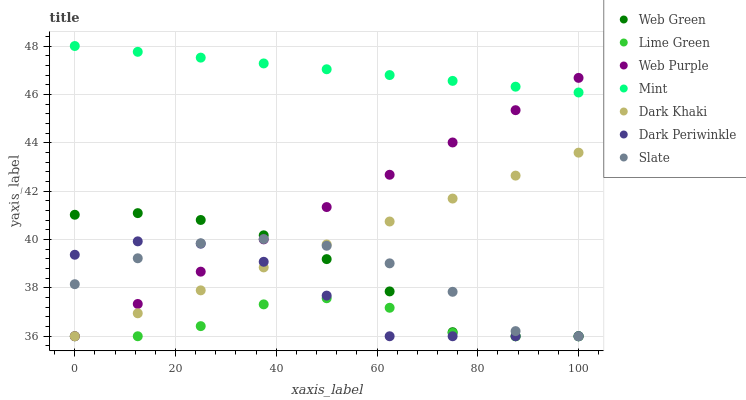Does Lime Green have the minimum area under the curve?
Answer yes or no. Yes. Does Mint have the maximum area under the curve?
Answer yes or no. Yes. Does Slate have the minimum area under the curve?
Answer yes or no. No. Does Slate have the maximum area under the curve?
Answer yes or no. No. Is Dark Khaki the smoothest?
Answer yes or no. Yes. Is Slate the roughest?
Answer yes or no. Yes. Is Web Green the smoothest?
Answer yes or no. No. Is Web Green the roughest?
Answer yes or no. No. Does Lime Green have the lowest value?
Answer yes or no. Yes. Does Mint have the lowest value?
Answer yes or no. No. Does Mint have the highest value?
Answer yes or no. Yes. Does Slate have the highest value?
Answer yes or no. No. Is Dark Khaki less than Mint?
Answer yes or no. Yes. Is Mint greater than Lime Green?
Answer yes or no. Yes. Does Web Green intersect Lime Green?
Answer yes or no. Yes. Is Web Green less than Lime Green?
Answer yes or no. No. Is Web Green greater than Lime Green?
Answer yes or no. No. Does Dark Khaki intersect Mint?
Answer yes or no. No. 